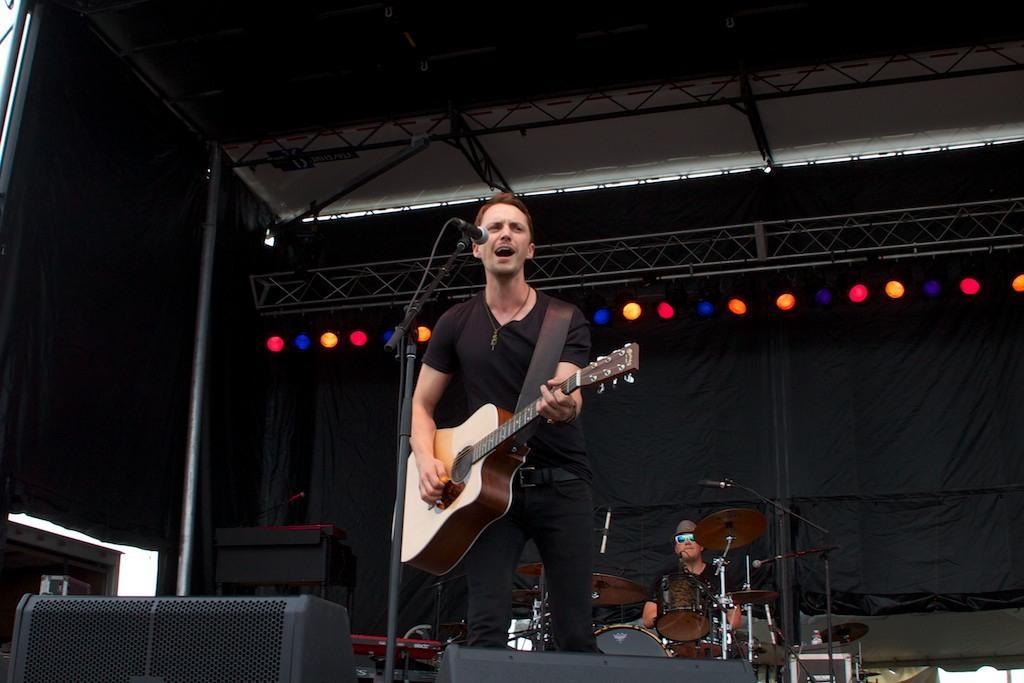Describe this image in one or two sentences. The picture is taken on the stage where in the middle the person is wearing a black dress and playing a guitar and singing in front of the microphone and in front of him there are speakers and behind him there is one person sitting and playing the drums and he is wearing hat and glasses and behind them there is a big black curtain and some lights on the stage upon them. 